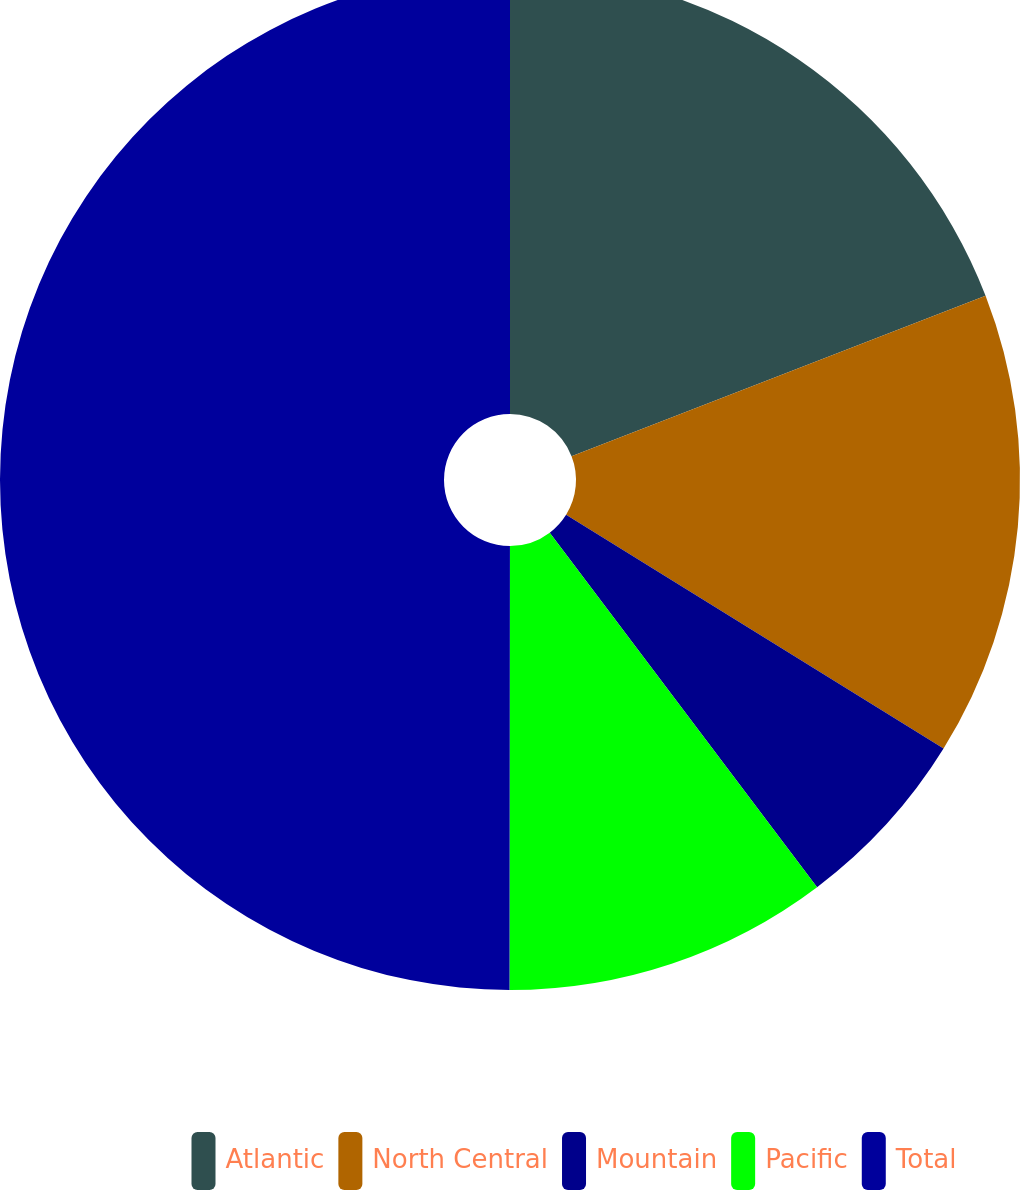Convert chart to OTSL. <chart><loc_0><loc_0><loc_500><loc_500><pie_chart><fcel>Atlantic<fcel>North Central<fcel>Mountain<fcel>Pacific<fcel>Total<nl><fcel>19.12%<fcel>14.71%<fcel>5.89%<fcel>10.3%<fcel>49.99%<nl></chart> 